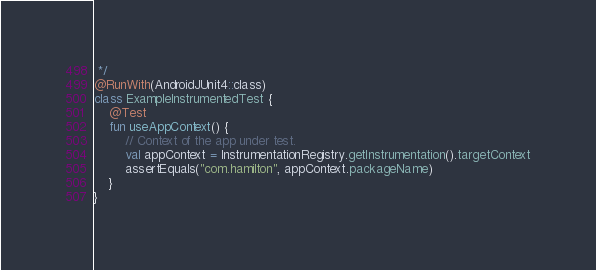Convert code to text. <code><loc_0><loc_0><loc_500><loc_500><_Kotlin_> */
@RunWith(AndroidJUnit4::class)
class ExampleInstrumentedTest {
    @Test
    fun useAppContext() {
        // Context of the app under test.
        val appContext = InstrumentationRegistry.getInstrumentation().targetContext
        assertEquals("com.hamilton", appContext.packageName)
    }
}</code> 